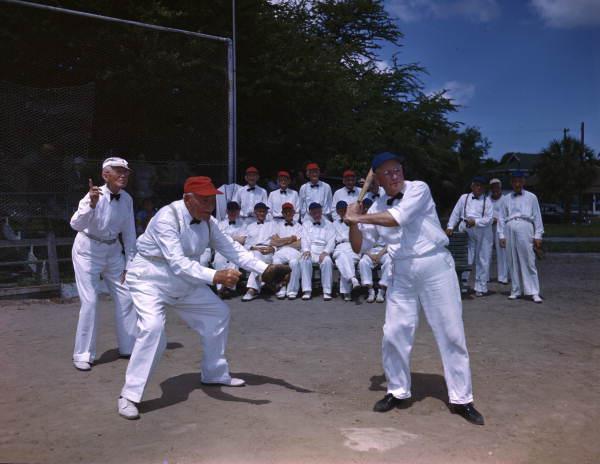How many red hats are shown?
Give a very brief answer. 6. How many people are in the photo?
Give a very brief answer. 7. 